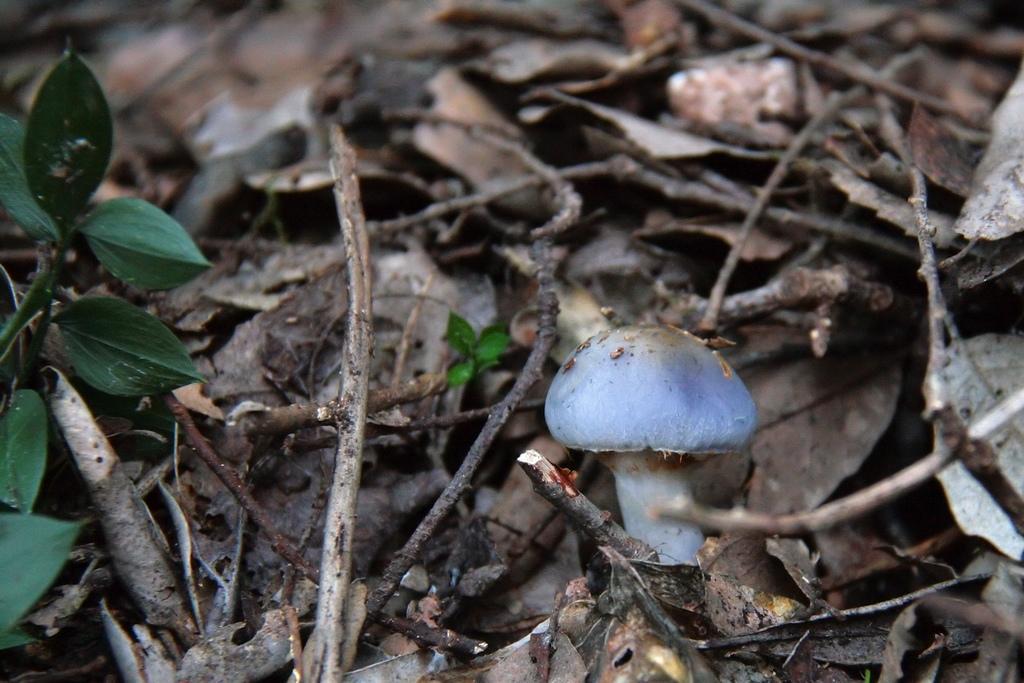How would you summarize this image in a sentence or two? In this picture I can see a mushroom in the middle, there are dried sticks and leaves. On the left side there is a green plant. 